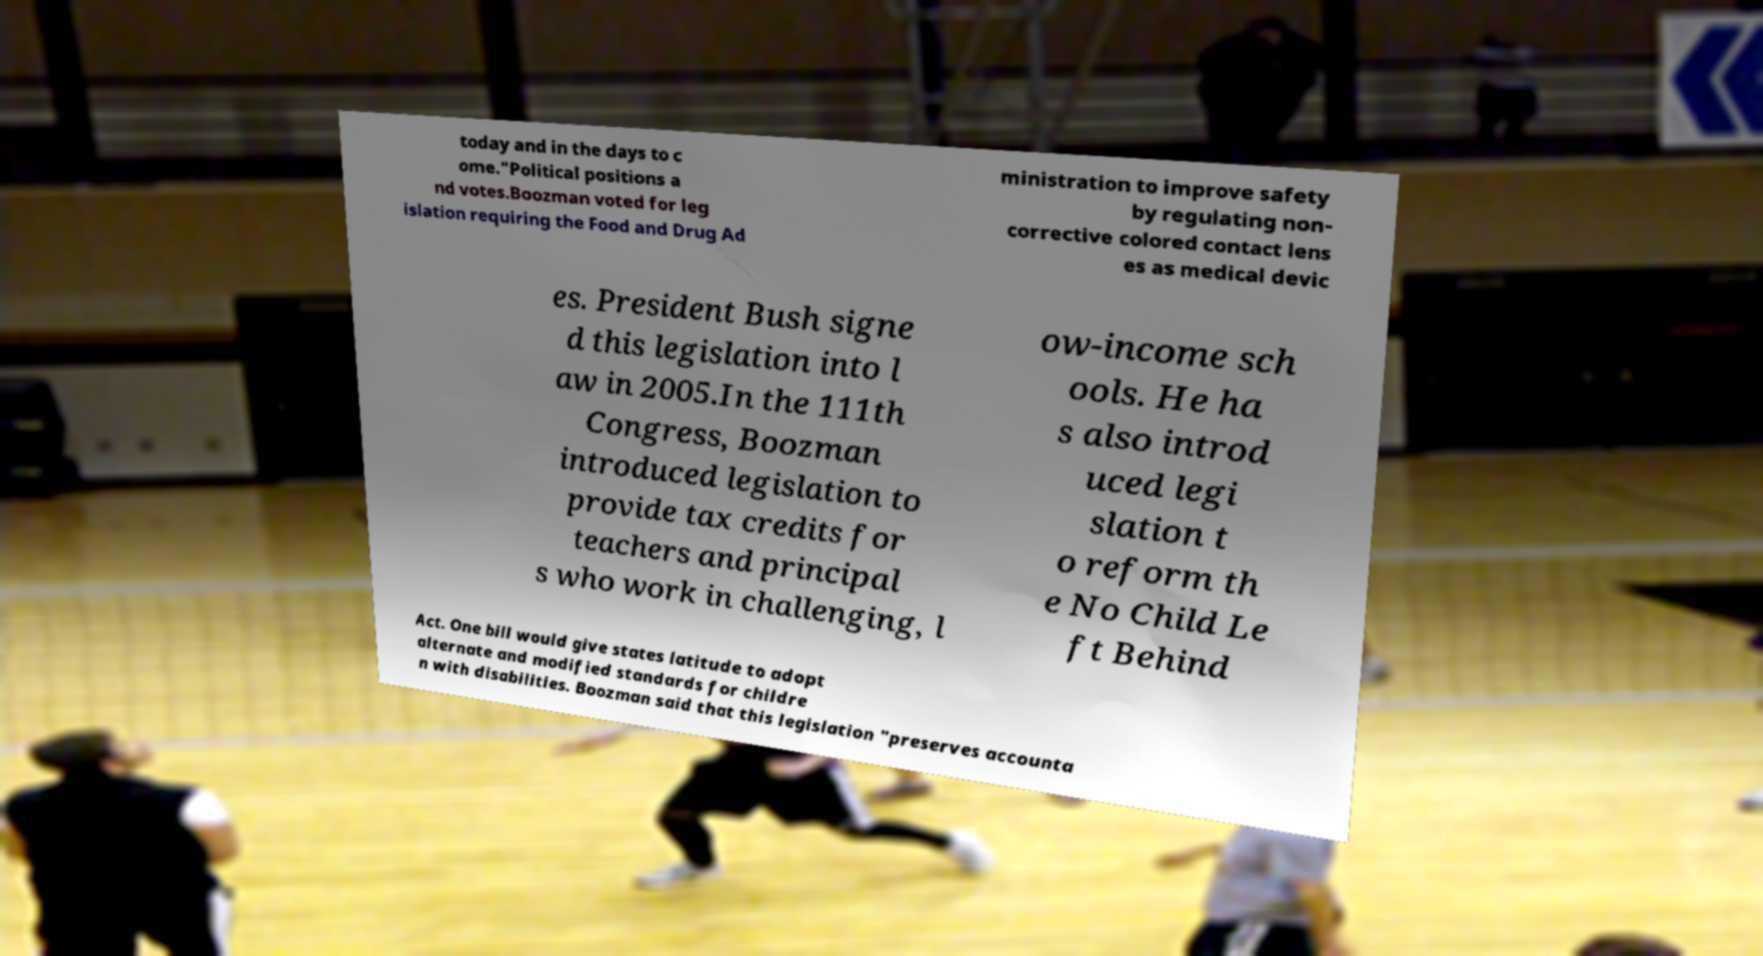Please identify and transcribe the text found in this image. today and in the days to c ome."Political positions a nd votes.Boozman voted for leg islation requiring the Food and Drug Ad ministration to improve safety by regulating non- corrective colored contact lens es as medical devic es. President Bush signe d this legislation into l aw in 2005.In the 111th Congress, Boozman introduced legislation to provide tax credits for teachers and principal s who work in challenging, l ow-income sch ools. He ha s also introd uced legi slation t o reform th e No Child Le ft Behind Act. One bill would give states latitude to adopt alternate and modified standards for childre n with disabilities. Boozman said that this legislation "preserves accounta 